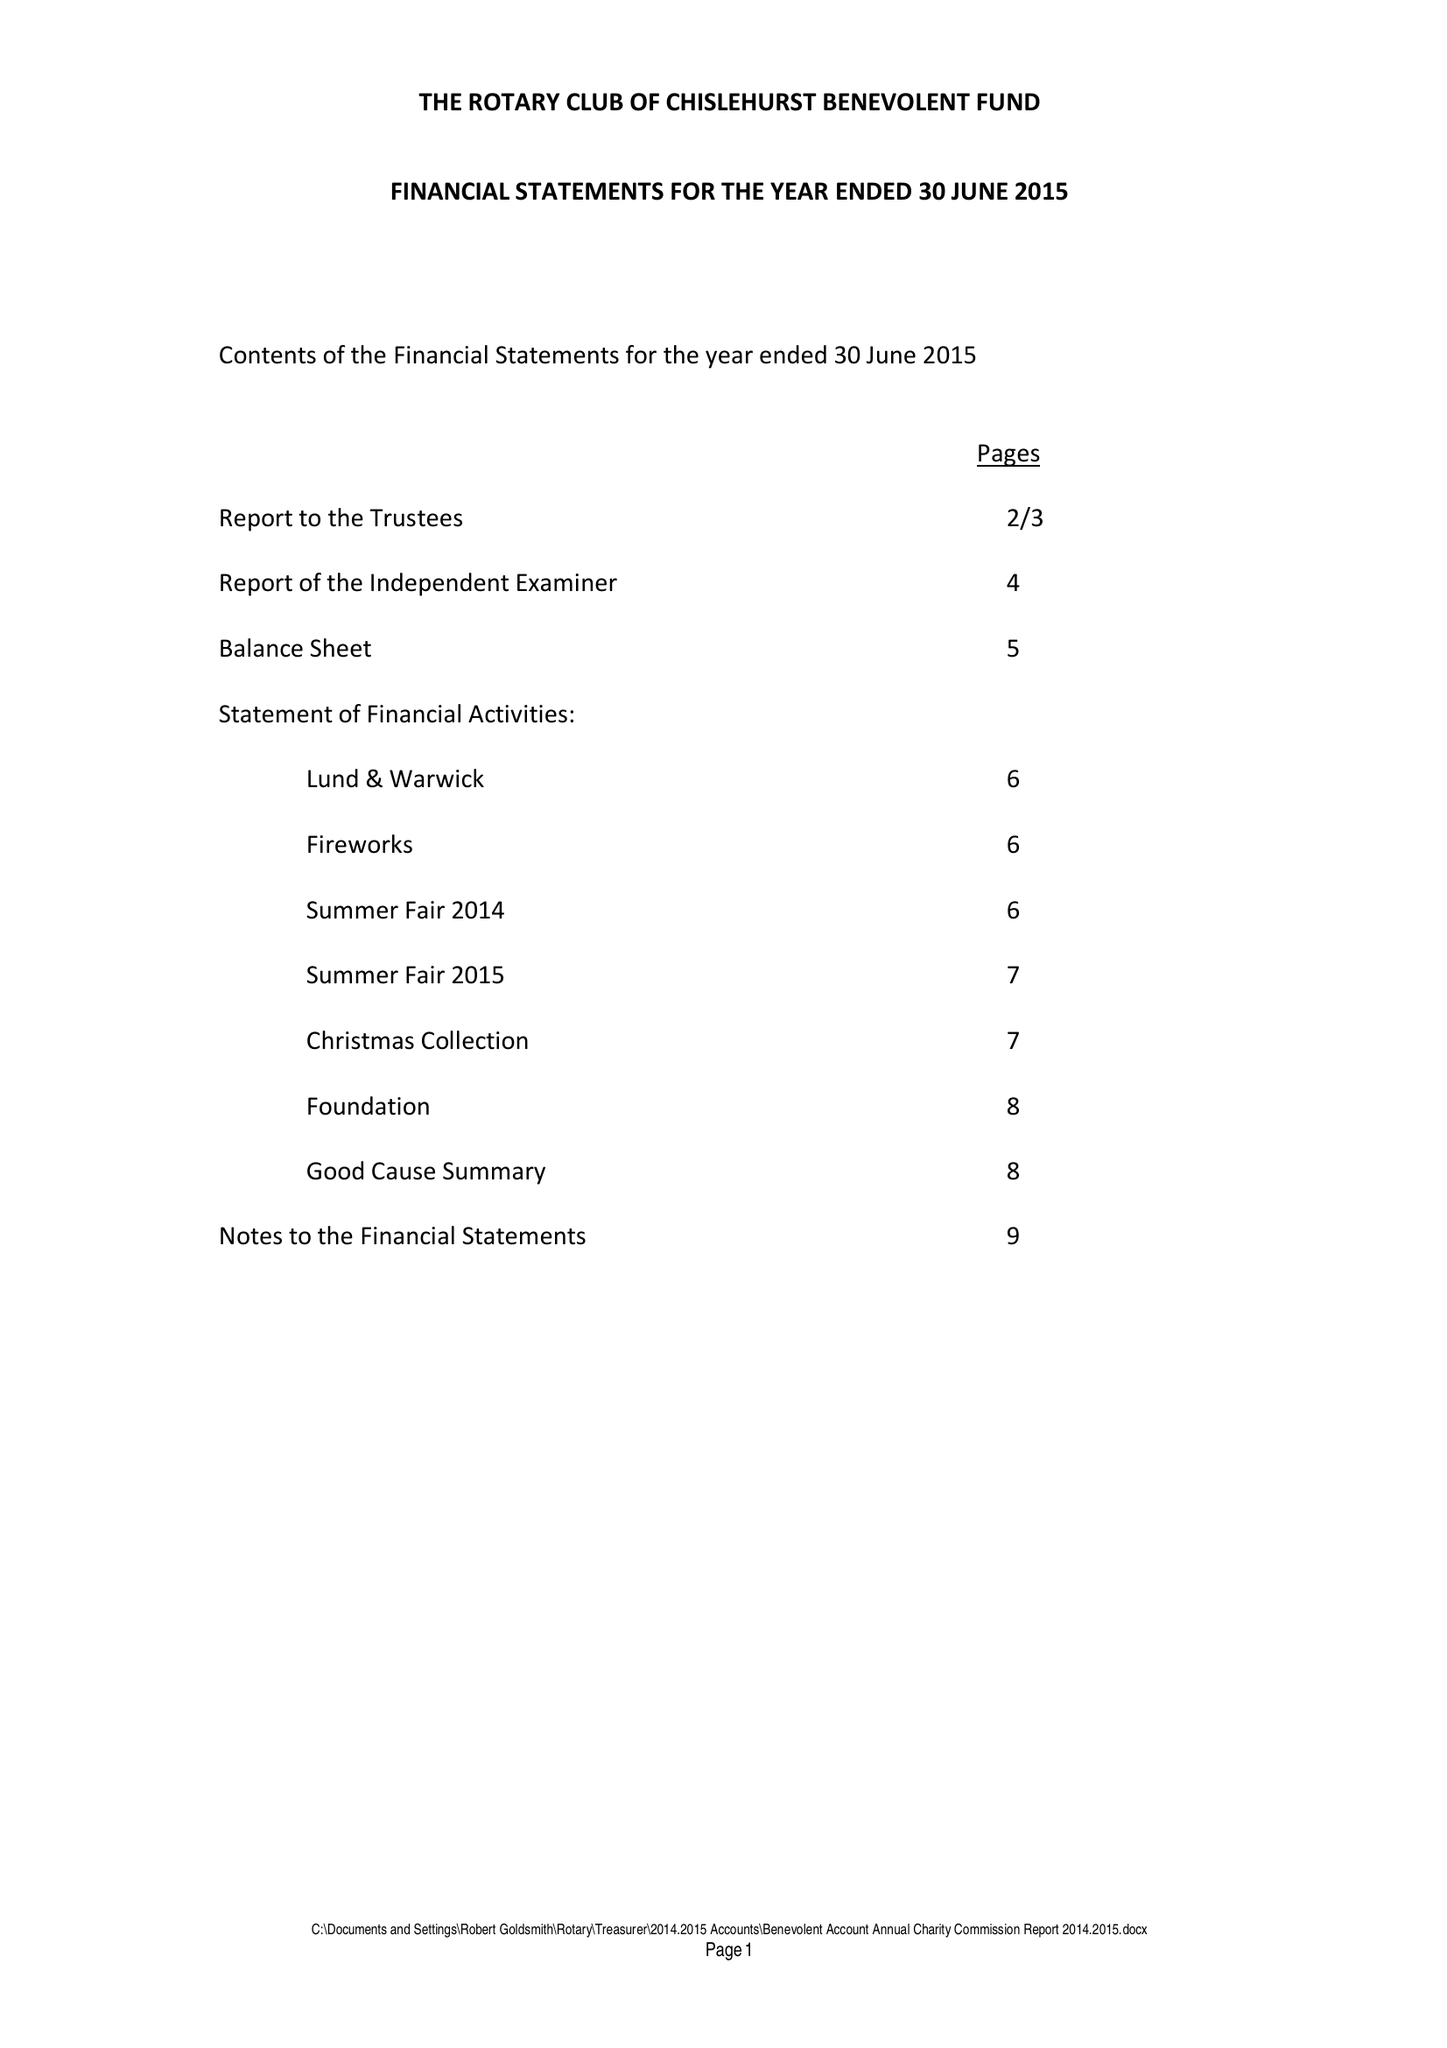What is the value for the address__postcode?
Answer the question using a single word or phrase. BR6 7RS 